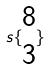Convert formula to latex. <formula><loc_0><loc_0><loc_500><loc_500>s \{ \begin{matrix} 8 \\ 3 \end{matrix} \}</formula> 